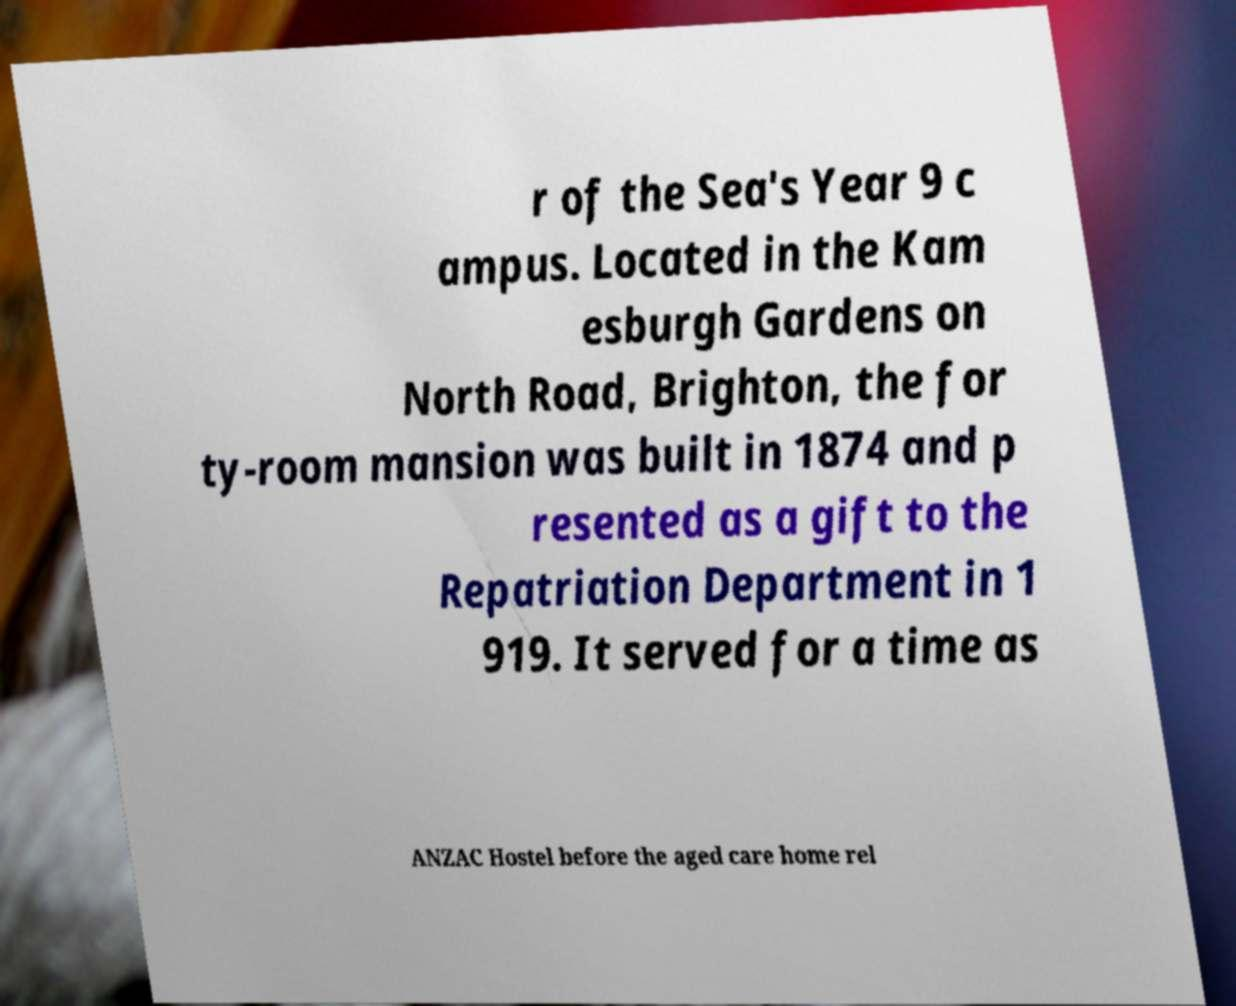There's text embedded in this image that I need extracted. Can you transcribe it verbatim? r of the Sea's Year 9 c ampus. Located in the Kam esburgh Gardens on North Road, Brighton, the for ty-room mansion was built in 1874 and p resented as a gift to the Repatriation Department in 1 919. It served for a time as ANZAC Hostel before the aged care home rel 